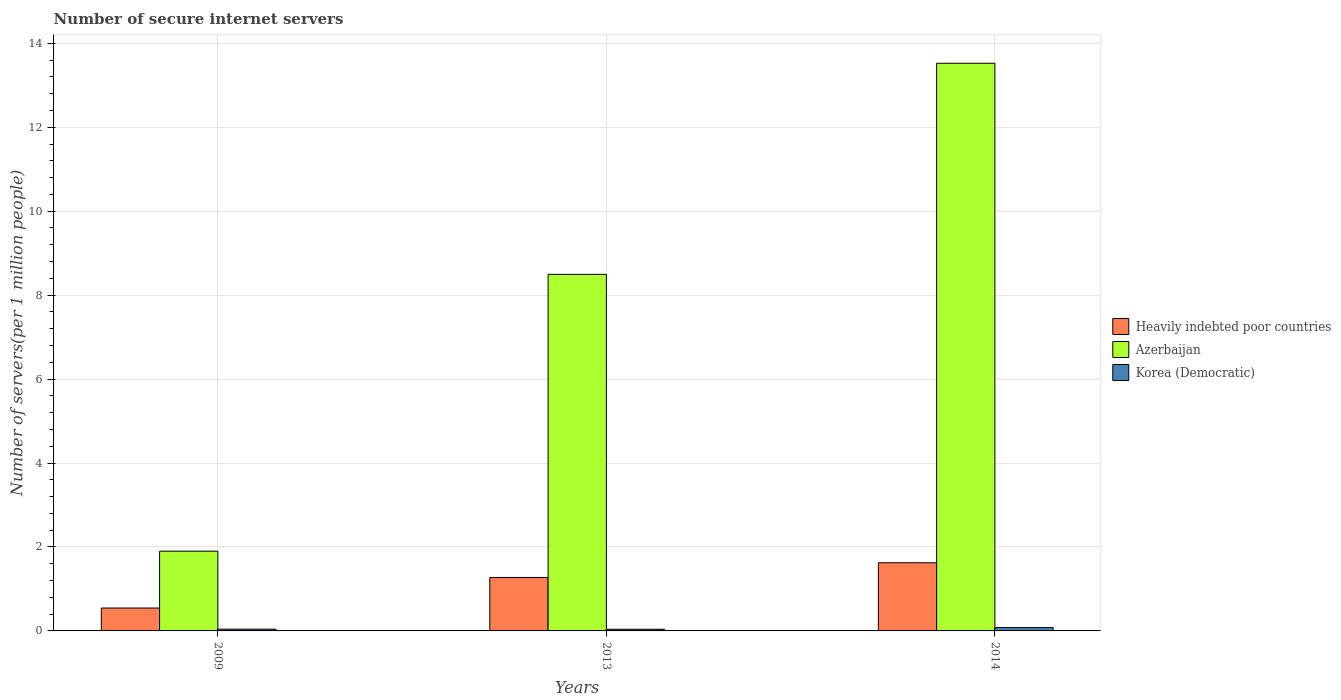Are the number of bars per tick equal to the number of legend labels?
Make the answer very short. Yes. How many bars are there on the 2nd tick from the left?
Ensure brevity in your answer.  3. What is the label of the 2nd group of bars from the left?
Make the answer very short. 2013. What is the number of secure internet servers in Korea (Democratic) in 2009?
Your answer should be very brief. 0.04. Across all years, what is the maximum number of secure internet servers in Heavily indebted poor countries?
Offer a very short reply. 1.62. Across all years, what is the minimum number of secure internet servers in Korea (Democratic)?
Provide a succinct answer. 0.04. What is the total number of secure internet servers in Korea (Democratic) in the graph?
Keep it short and to the point. 0.16. What is the difference between the number of secure internet servers in Azerbaijan in 2009 and that in 2013?
Your answer should be compact. -6.6. What is the difference between the number of secure internet servers in Korea (Democratic) in 2014 and the number of secure internet servers in Azerbaijan in 2013?
Your response must be concise. -8.42. What is the average number of secure internet servers in Heavily indebted poor countries per year?
Make the answer very short. 1.15. In the year 2013, what is the difference between the number of secure internet servers in Korea (Democratic) and number of secure internet servers in Heavily indebted poor countries?
Provide a succinct answer. -1.23. What is the ratio of the number of secure internet servers in Azerbaijan in 2009 to that in 2014?
Your answer should be very brief. 0.14. Is the number of secure internet servers in Heavily indebted poor countries in 2009 less than that in 2013?
Your answer should be compact. Yes. What is the difference between the highest and the second highest number of secure internet servers in Korea (Democratic)?
Make the answer very short. 0.04. What is the difference between the highest and the lowest number of secure internet servers in Azerbaijan?
Offer a very short reply. 11.63. In how many years, is the number of secure internet servers in Heavily indebted poor countries greater than the average number of secure internet servers in Heavily indebted poor countries taken over all years?
Offer a very short reply. 2. Is the sum of the number of secure internet servers in Korea (Democratic) in 2009 and 2013 greater than the maximum number of secure internet servers in Azerbaijan across all years?
Keep it short and to the point. No. What does the 3rd bar from the left in 2013 represents?
Keep it short and to the point. Korea (Democratic). What does the 1st bar from the right in 2014 represents?
Keep it short and to the point. Korea (Democratic). Is it the case that in every year, the sum of the number of secure internet servers in Azerbaijan and number of secure internet servers in Heavily indebted poor countries is greater than the number of secure internet servers in Korea (Democratic)?
Keep it short and to the point. Yes. How many bars are there?
Your answer should be very brief. 9. Are the values on the major ticks of Y-axis written in scientific E-notation?
Your answer should be compact. No. Does the graph contain any zero values?
Provide a short and direct response. No. Does the graph contain grids?
Your response must be concise. Yes. What is the title of the graph?
Give a very brief answer. Number of secure internet servers. What is the label or title of the X-axis?
Offer a terse response. Years. What is the label or title of the Y-axis?
Ensure brevity in your answer.  Number of servers(per 1 million people). What is the Number of servers(per 1 million people) of Heavily indebted poor countries in 2009?
Your answer should be very brief. 0.55. What is the Number of servers(per 1 million people) of Azerbaijan in 2009?
Your answer should be very brief. 1.9. What is the Number of servers(per 1 million people) in Korea (Democratic) in 2009?
Make the answer very short. 0.04. What is the Number of servers(per 1 million people) in Heavily indebted poor countries in 2013?
Offer a terse response. 1.27. What is the Number of servers(per 1 million people) of Azerbaijan in 2013?
Ensure brevity in your answer.  8.5. What is the Number of servers(per 1 million people) of Korea (Democratic) in 2013?
Provide a short and direct response. 0.04. What is the Number of servers(per 1 million people) of Heavily indebted poor countries in 2014?
Make the answer very short. 1.62. What is the Number of servers(per 1 million people) in Azerbaijan in 2014?
Your answer should be compact. 13.53. What is the Number of servers(per 1 million people) in Korea (Democratic) in 2014?
Your answer should be very brief. 0.08. Across all years, what is the maximum Number of servers(per 1 million people) of Heavily indebted poor countries?
Your response must be concise. 1.62. Across all years, what is the maximum Number of servers(per 1 million people) of Azerbaijan?
Your response must be concise. 13.53. Across all years, what is the maximum Number of servers(per 1 million people) in Korea (Democratic)?
Your response must be concise. 0.08. Across all years, what is the minimum Number of servers(per 1 million people) of Heavily indebted poor countries?
Provide a succinct answer. 0.55. Across all years, what is the minimum Number of servers(per 1 million people) in Azerbaijan?
Offer a very short reply. 1.9. Across all years, what is the minimum Number of servers(per 1 million people) of Korea (Democratic)?
Your answer should be very brief. 0.04. What is the total Number of servers(per 1 million people) of Heavily indebted poor countries in the graph?
Offer a terse response. 3.44. What is the total Number of servers(per 1 million people) in Azerbaijan in the graph?
Your response must be concise. 23.92. What is the total Number of servers(per 1 million people) in Korea (Democratic) in the graph?
Your answer should be very brief. 0.16. What is the difference between the Number of servers(per 1 million people) in Heavily indebted poor countries in 2009 and that in 2013?
Keep it short and to the point. -0.73. What is the difference between the Number of servers(per 1 million people) of Azerbaijan in 2009 and that in 2013?
Your response must be concise. -6.6. What is the difference between the Number of servers(per 1 million people) of Korea (Democratic) in 2009 and that in 2013?
Make the answer very short. 0. What is the difference between the Number of servers(per 1 million people) in Heavily indebted poor countries in 2009 and that in 2014?
Ensure brevity in your answer.  -1.08. What is the difference between the Number of servers(per 1 million people) in Azerbaijan in 2009 and that in 2014?
Keep it short and to the point. -11.63. What is the difference between the Number of servers(per 1 million people) of Korea (Democratic) in 2009 and that in 2014?
Your answer should be compact. -0.04. What is the difference between the Number of servers(per 1 million people) of Heavily indebted poor countries in 2013 and that in 2014?
Your answer should be compact. -0.35. What is the difference between the Number of servers(per 1 million people) in Azerbaijan in 2013 and that in 2014?
Keep it short and to the point. -5.03. What is the difference between the Number of servers(per 1 million people) of Korea (Democratic) in 2013 and that in 2014?
Give a very brief answer. -0.04. What is the difference between the Number of servers(per 1 million people) of Heavily indebted poor countries in 2009 and the Number of servers(per 1 million people) of Azerbaijan in 2013?
Provide a succinct answer. -7.95. What is the difference between the Number of servers(per 1 million people) in Heavily indebted poor countries in 2009 and the Number of servers(per 1 million people) in Korea (Democratic) in 2013?
Offer a terse response. 0.51. What is the difference between the Number of servers(per 1 million people) in Azerbaijan in 2009 and the Number of servers(per 1 million people) in Korea (Democratic) in 2013?
Offer a terse response. 1.86. What is the difference between the Number of servers(per 1 million people) in Heavily indebted poor countries in 2009 and the Number of servers(per 1 million people) in Azerbaijan in 2014?
Provide a short and direct response. -12.98. What is the difference between the Number of servers(per 1 million people) in Heavily indebted poor countries in 2009 and the Number of servers(per 1 million people) in Korea (Democratic) in 2014?
Offer a very short reply. 0.47. What is the difference between the Number of servers(per 1 million people) in Azerbaijan in 2009 and the Number of servers(per 1 million people) in Korea (Democratic) in 2014?
Provide a short and direct response. 1.82. What is the difference between the Number of servers(per 1 million people) in Heavily indebted poor countries in 2013 and the Number of servers(per 1 million people) in Azerbaijan in 2014?
Provide a short and direct response. -12.25. What is the difference between the Number of servers(per 1 million people) of Heavily indebted poor countries in 2013 and the Number of servers(per 1 million people) of Korea (Democratic) in 2014?
Make the answer very short. 1.19. What is the difference between the Number of servers(per 1 million people) of Azerbaijan in 2013 and the Number of servers(per 1 million people) of Korea (Democratic) in 2014?
Offer a terse response. 8.42. What is the average Number of servers(per 1 million people) in Heavily indebted poor countries per year?
Provide a short and direct response. 1.15. What is the average Number of servers(per 1 million people) in Azerbaijan per year?
Give a very brief answer. 7.97. What is the average Number of servers(per 1 million people) in Korea (Democratic) per year?
Your response must be concise. 0.05. In the year 2009, what is the difference between the Number of servers(per 1 million people) of Heavily indebted poor countries and Number of servers(per 1 million people) of Azerbaijan?
Your answer should be compact. -1.35. In the year 2009, what is the difference between the Number of servers(per 1 million people) in Heavily indebted poor countries and Number of servers(per 1 million people) in Korea (Democratic)?
Your response must be concise. 0.5. In the year 2009, what is the difference between the Number of servers(per 1 million people) in Azerbaijan and Number of servers(per 1 million people) in Korea (Democratic)?
Your answer should be compact. 1.86. In the year 2013, what is the difference between the Number of servers(per 1 million people) in Heavily indebted poor countries and Number of servers(per 1 million people) in Azerbaijan?
Your answer should be very brief. -7.22. In the year 2013, what is the difference between the Number of servers(per 1 million people) in Heavily indebted poor countries and Number of servers(per 1 million people) in Korea (Democratic)?
Your answer should be compact. 1.23. In the year 2013, what is the difference between the Number of servers(per 1 million people) in Azerbaijan and Number of servers(per 1 million people) in Korea (Democratic)?
Your answer should be very brief. 8.46. In the year 2014, what is the difference between the Number of servers(per 1 million people) of Heavily indebted poor countries and Number of servers(per 1 million people) of Azerbaijan?
Provide a succinct answer. -11.9. In the year 2014, what is the difference between the Number of servers(per 1 million people) of Heavily indebted poor countries and Number of servers(per 1 million people) of Korea (Democratic)?
Your answer should be very brief. 1.54. In the year 2014, what is the difference between the Number of servers(per 1 million people) in Azerbaijan and Number of servers(per 1 million people) in Korea (Democratic)?
Your answer should be compact. 13.45. What is the ratio of the Number of servers(per 1 million people) in Heavily indebted poor countries in 2009 to that in 2013?
Keep it short and to the point. 0.43. What is the ratio of the Number of servers(per 1 million people) of Azerbaijan in 2009 to that in 2013?
Your response must be concise. 0.22. What is the ratio of the Number of servers(per 1 million people) of Korea (Democratic) in 2009 to that in 2013?
Make the answer very short. 1.02. What is the ratio of the Number of servers(per 1 million people) in Heavily indebted poor countries in 2009 to that in 2014?
Make the answer very short. 0.34. What is the ratio of the Number of servers(per 1 million people) of Azerbaijan in 2009 to that in 2014?
Give a very brief answer. 0.14. What is the ratio of the Number of servers(per 1 million people) of Korea (Democratic) in 2009 to that in 2014?
Give a very brief answer. 0.51. What is the ratio of the Number of servers(per 1 million people) in Heavily indebted poor countries in 2013 to that in 2014?
Offer a terse response. 0.78. What is the ratio of the Number of servers(per 1 million people) in Azerbaijan in 2013 to that in 2014?
Offer a terse response. 0.63. What is the ratio of the Number of servers(per 1 million people) in Korea (Democratic) in 2013 to that in 2014?
Your answer should be compact. 0.5. What is the difference between the highest and the second highest Number of servers(per 1 million people) in Azerbaijan?
Your answer should be very brief. 5.03. What is the difference between the highest and the second highest Number of servers(per 1 million people) of Korea (Democratic)?
Your answer should be compact. 0.04. What is the difference between the highest and the lowest Number of servers(per 1 million people) of Heavily indebted poor countries?
Ensure brevity in your answer.  1.08. What is the difference between the highest and the lowest Number of servers(per 1 million people) of Azerbaijan?
Provide a short and direct response. 11.63. What is the difference between the highest and the lowest Number of servers(per 1 million people) in Korea (Democratic)?
Give a very brief answer. 0.04. 